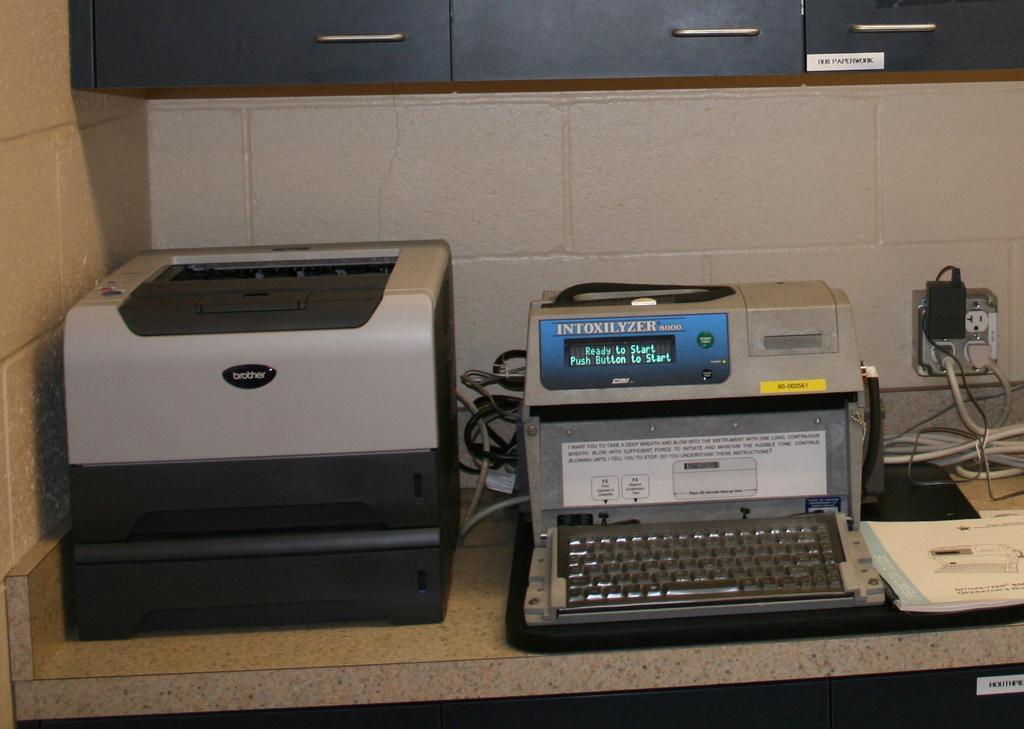In one or two sentences, can you explain what this image depicts? In this image we can see a printer and a typewriter placed on the desk. In addition to these we can see electric shaft, cables and a book. 